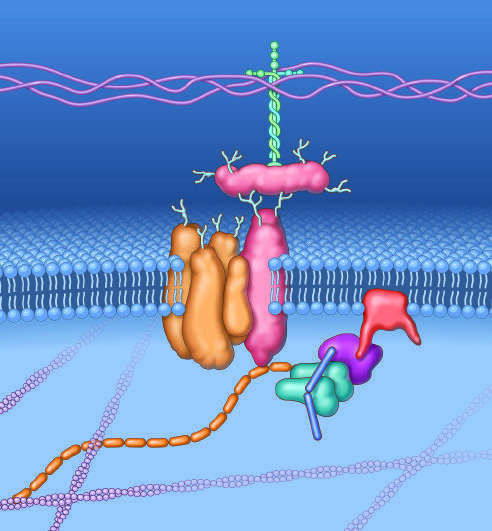what is a key set of connections made by?
Answer the question using a single word or phrase. Dystrophin 